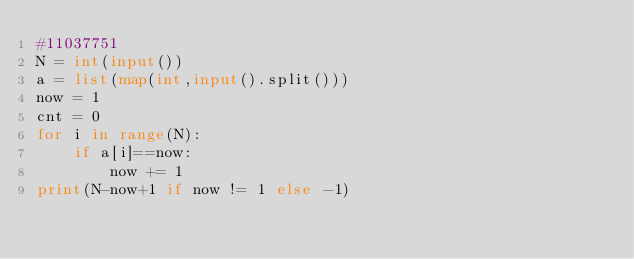Convert code to text. <code><loc_0><loc_0><loc_500><loc_500><_Python_>#11037751
N = int(input())
a = list(map(int,input().split()))
now = 1
cnt = 0
for i in range(N):
    if a[i]==now:
        now += 1
print(N-now+1 if now != 1 else -1)</code> 